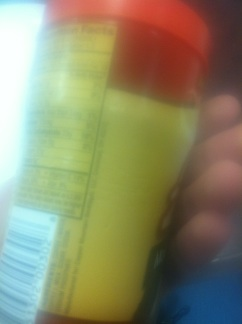Can you describe any visible text or elements you can distinguish in this image? The image is blurry, but it appears to showcase a label with some sort of nutritional information. I can make out lines that typically represent the format of ingredients or nutritional facts. The rest of the text is unclear due to the image quality. 